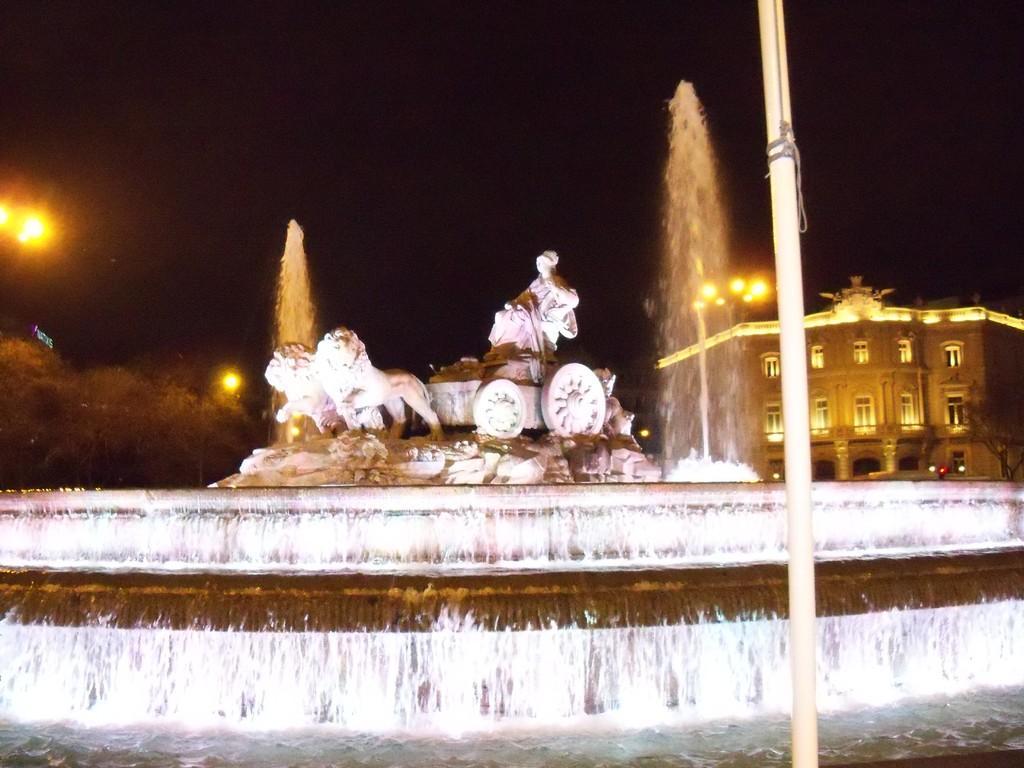Could you give a brief overview of what you see in this image? In his image in the front there is a pole. In the center there is a water fountain and there are statues and in the background there are trees, poles and there is a building. 